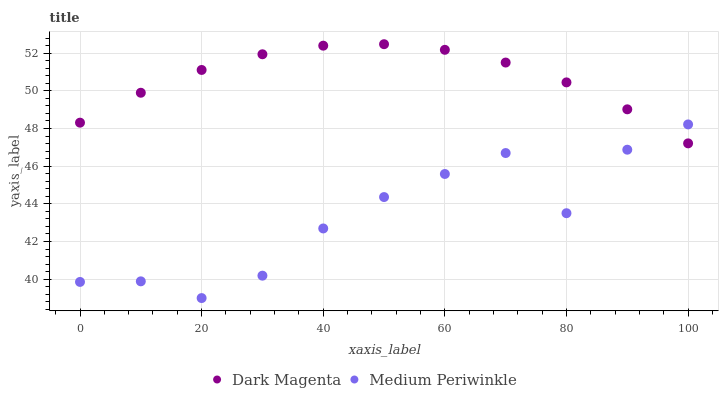Does Medium Periwinkle have the minimum area under the curve?
Answer yes or no. Yes. Does Dark Magenta have the maximum area under the curve?
Answer yes or no. Yes. Does Dark Magenta have the minimum area under the curve?
Answer yes or no. No. Is Dark Magenta the smoothest?
Answer yes or no. Yes. Is Medium Periwinkle the roughest?
Answer yes or no. Yes. Is Dark Magenta the roughest?
Answer yes or no. No. Does Medium Periwinkle have the lowest value?
Answer yes or no. Yes. Does Dark Magenta have the lowest value?
Answer yes or no. No. Does Dark Magenta have the highest value?
Answer yes or no. Yes. Does Dark Magenta intersect Medium Periwinkle?
Answer yes or no. Yes. Is Dark Magenta less than Medium Periwinkle?
Answer yes or no. No. Is Dark Magenta greater than Medium Periwinkle?
Answer yes or no. No. 